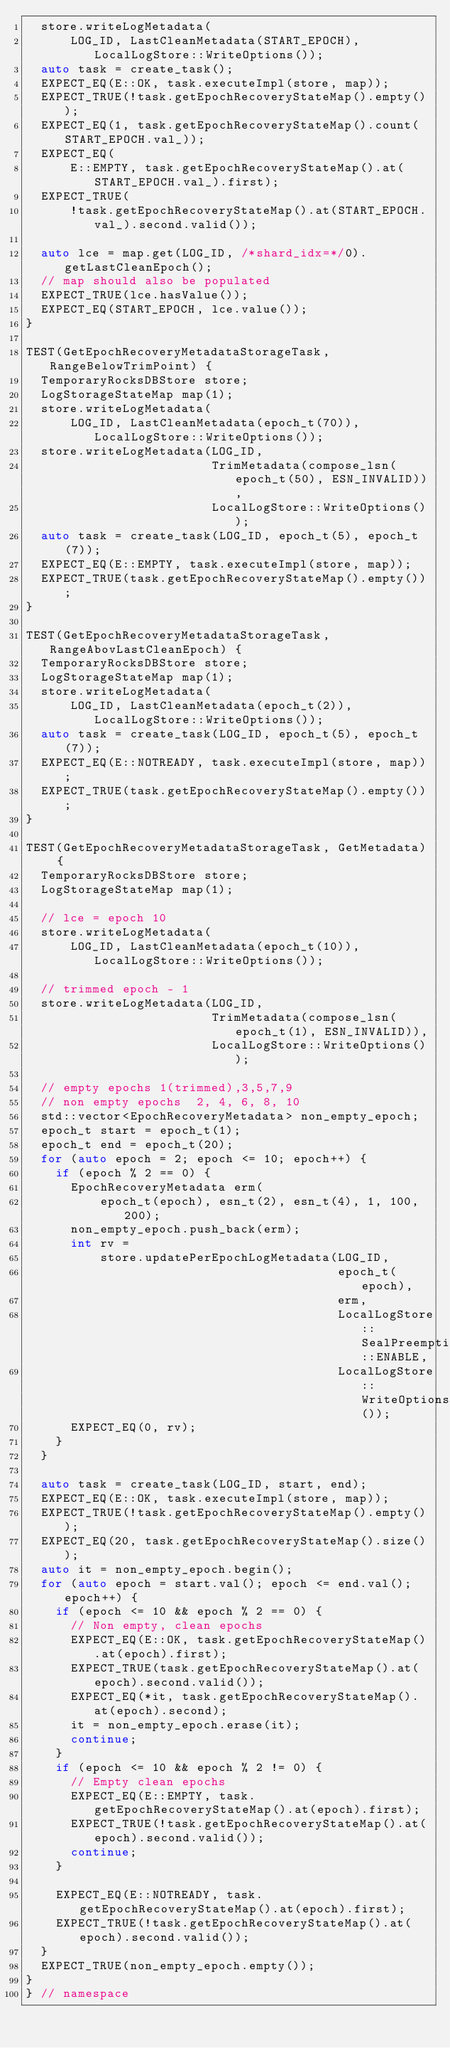Convert code to text. <code><loc_0><loc_0><loc_500><loc_500><_C++_>  store.writeLogMetadata(
      LOG_ID, LastCleanMetadata(START_EPOCH), LocalLogStore::WriteOptions());
  auto task = create_task();
  EXPECT_EQ(E::OK, task.executeImpl(store, map));
  EXPECT_TRUE(!task.getEpochRecoveryStateMap().empty());
  EXPECT_EQ(1, task.getEpochRecoveryStateMap().count(START_EPOCH.val_));
  EXPECT_EQ(
      E::EMPTY, task.getEpochRecoveryStateMap().at(START_EPOCH.val_).first);
  EXPECT_TRUE(
      !task.getEpochRecoveryStateMap().at(START_EPOCH.val_).second.valid());

  auto lce = map.get(LOG_ID, /*shard_idx=*/0).getLastCleanEpoch();
  // map should also be populated
  EXPECT_TRUE(lce.hasValue());
  EXPECT_EQ(START_EPOCH, lce.value());
}

TEST(GetEpochRecoveryMetadataStorageTask, RangeBelowTrimPoint) {
  TemporaryRocksDBStore store;
  LogStorageStateMap map(1);
  store.writeLogMetadata(
      LOG_ID, LastCleanMetadata(epoch_t(70)), LocalLogStore::WriteOptions());
  store.writeLogMetadata(LOG_ID,
                         TrimMetadata(compose_lsn(epoch_t(50), ESN_INVALID)),
                         LocalLogStore::WriteOptions());
  auto task = create_task(LOG_ID, epoch_t(5), epoch_t(7));
  EXPECT_EQ(E::EMPTY, task.executeImpl(store, map));
  EXPECT_TRUE(task.getEpochRecoveryStateMap().empty());
}

TEST(GetEpochRecoveryMetadataStorageTask, RangeAbovLastCleanEpoch) {
  TemporaryRocksDBStore store;
  LogStorageStateMap map(1);
  store.writeLogMetadata(
      LOG_ID, LastCleanMetadata(epoch_t(2)), LocalLogStore::WriteOptions());
  auto task = create_task(LOG_ID, epoch_t(5), epoch_t(7));
  EXPECT_EQ(E::NOTREADY, task.executeImpl(store, map));
  EXPECT_TRUE(task.getEpochRecoveryStateMap().empty());
}

TEST(GetEpochRecoveryMetadataStorageTask, GetMetadata) {
  TemporaryRocksDBStore store;
  LogStorageStateMap map(1);

  // lce = epoch 10
  store.writeLogMetadata(
      LOG_ID, LastCleanMetadata(epoch_t(10)), LocalLogStore::WriteOptions());

  // trimmed epoch - 1
  store.writeLogMetadata(LOG_ID,
                         TrimMetadata(compose_lsn(epoch_t(1), ESN_INVALID)),
                         LocalLogStore::WriteOptions());

  // empty epochs 1(trimmed),3,5,7,9
  // non empty epochs  2, 4, 6, 8, 10
  std::vector<EpochRecoveryMetadata> non_empty_epoch;
  epoch_t start = epoch_t(1);
  epoch_t end = epoch_t(20);
  for (auto epoch = 2; epoch <= 10; epoch++) {
    if (epoch % 2 == 0) {
      EpochRecoveryMetadata erm(
          epoch_t(epoch), esn_t(2), esn_t(4), 1, 100, 200);
      non_empty_epoch.push_back(erm);
      int rv =
          store.updatePerEpochLogMetadata(LOG_ID,
                                          epoch_t(epoch),
                                          erm,
                                          LocalLogStore::SealPreemption::ENABLE,
                                          LocalLogStore::WriteOptions());
      EXPECT_EQ(0, rv);
    }
  }

  auto task = create_task(LOG_ID, start, end);
  EXPECT_EQ(E::OK, task.executeImpl(store, map));
  EXPECT_TRUE(!task.getEpochRecoveryStateMap().empty());
  EXPECT_EQ(20, task.getEpochRecoveryStateMap().size());
  auto it = non_empty_epoch.begin();
  for (auto epoch = start.val(); epoch <= end.val(); epoch++) {
    if (epoch <= 10 && epoch % 2 == 0) {
      // Non empty, clean epochs
      EXPECT_EQ(E::OK, task.getEpochRecoveryStateMap().at(epoch).first);
      EXPECT_TRUE(task.getEpochRecoveryStateMap().at(epoch).second.valid());
      EXPECT_EQ(*it, task.getEpochRecoveryStateMap().at(epoch).second);
      it = non_empty_epoch.erase(it);
      continue;
    }
    if (epoch <= 10 && epoch % 2 != 0) {
      // Empty clean epochs
      EXPECT_EQ(E::EMPTY, task.getEpochRecoveryStateMap().at(epoch).first);
      EXPECT_TRUE(!task.getEpochRecoveryStateMap().at(epoch).second.valid());
      continue;
    }

    EXPECT_EQ(E::NOTREADY, task.getEpochRecoveryStateMap().at(epoch).first);
    EXPECT_TRUE(!task.getEpochRecoveryStateMap().at(epoch).second.valid());
  }
  EXPECT_TRUE(non_empty_epoch.empty());
}
} // namespace
</code> 